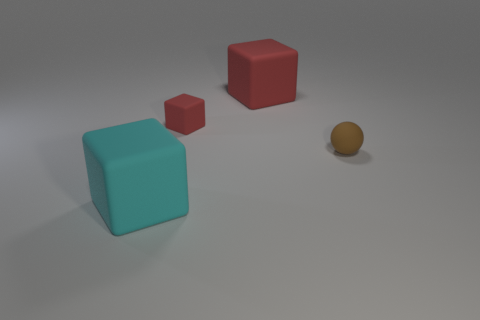Add 3 cyan cubes. How many objects exist? 7 Subtract all spheres. How many objects are left? 3 Add 3 matte balls. How many matte balls are left? 4 Add 3 tiny red rubber things. How many tiny red rubber things exist? 4 Subtract 1 brown spheres. How many objects are left? 3 Subtract all tiny cubes. Subtract all large cyan things. How many objects are left? 2 